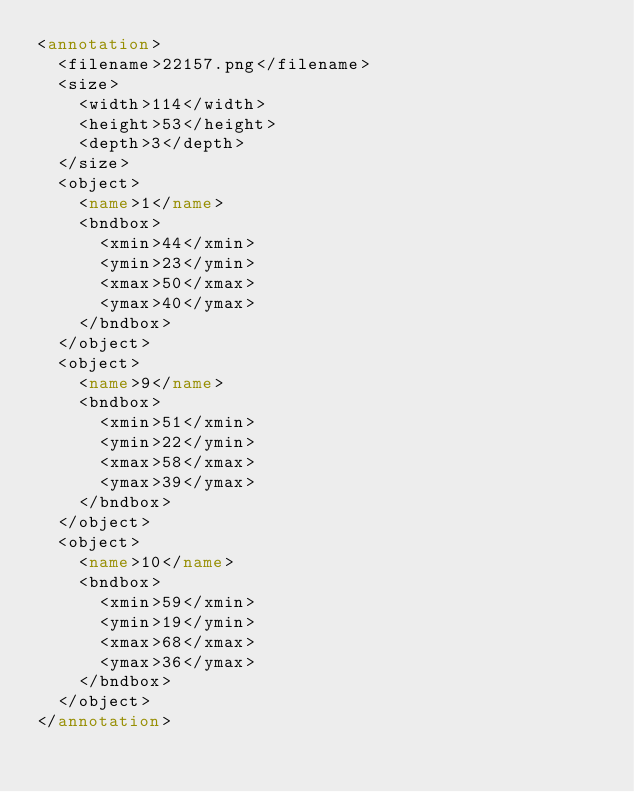<code> <loc_0><loc_0><loc_500><loc_500><_XML_><annotation>
  <filename>22157.png</filename>
  <size>
    <width>114</width>
    <height>53</height>
    <depth>3</depth>
  </size>
  <object>
    <name>1</name>
    <bndbox>
      <xmin>44</xmin>
      <ymin>23</ymin>
      <xmax>50</xmax>
      <ymax>40</ymax>
    </bndbox>
  </object>
  <object>
    <name>9</name>
    <bndbox>
      <xmin>51</xmin>
      <ymin>22</ymin>
      <xmax>58</xmax>
      <ymax>39</ymax>
    </bndbox>
  </object>
  <object>
    <name>10</name>
    <bndbox>
      <xmin>59</xmin>
      <ymin>19</ymin>
      <xmax>68</xmax>
      <ymax>36</ymax>
    </bndbox>
  </object>
</annotation>
</code> 